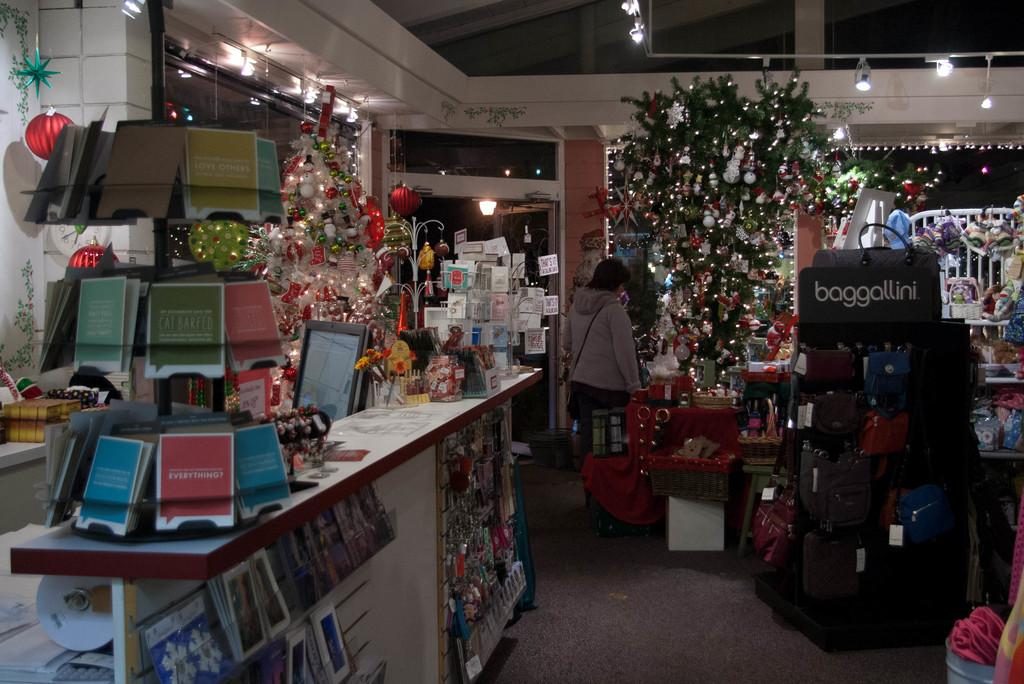<image>
Offer a succinct explanation of the picture presented. A store that carries the brand "baggallini" is decorated for Christmas. 